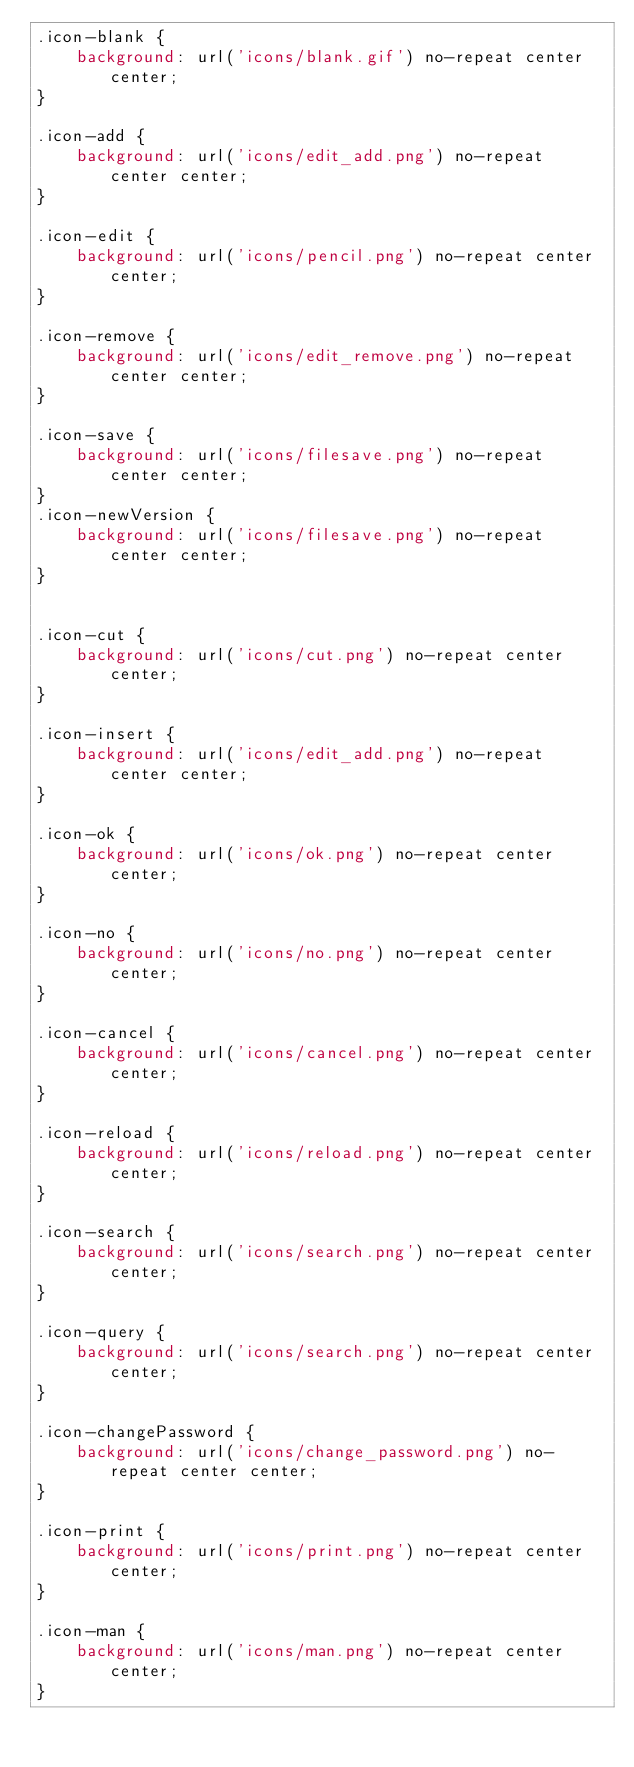<code> <loc_0><loc_0><loc_500><loc_500><_CSS_>.icon-blank {
    background: url('icons/blank.gif') no-repeat center center;
}

.icon-add {
    background: url('icons/edit_add.png') no-repeat center center;
}

.icon-edit {
    background: url('icons/pencil.png') no-repeat center center;
}

.icon-remove {
    background: url('icons/edit_remove.png') no-repeat center center;
}

.icon-save {
    background: url('icons/filesave.png') no-repeat center center;
}
.icon-newVersion {
    background: url('icons/filesave.png') no-repeat center center;
}


.icon-cut {
    background: url('icons/cut.png') no-repeat center center;
}

.icon-insert {
    background: url('icons/edit_add.png') no-repeat center center;
}

.icon-ok {
    background: url('icons/ok.png') no-repeat center center;
}

.icon-no {
    background: url('icons/no.png') no-repeat center center;
}

.icon-cancel {
    background: url('icons/cancel.png') no-repeat center center;
}

.icon-reload {
    background: url('icons/reload.png') no-repeat center center;
}

.icon-search {
    background: url('icons/search.png') no-repeat center center;
}

.icon-query {
    background: url('icons/search.png') no-repeat center center;
}

.icon-changePassword {
    background: url('icons/change_password.png') no-repeat center center;
}

.icon-print {
    background: url('icons/print.png') no-repeat center center;
}

.icon-man {
    background: url('icons/man.png') no-repeat center center;
}
</code> 